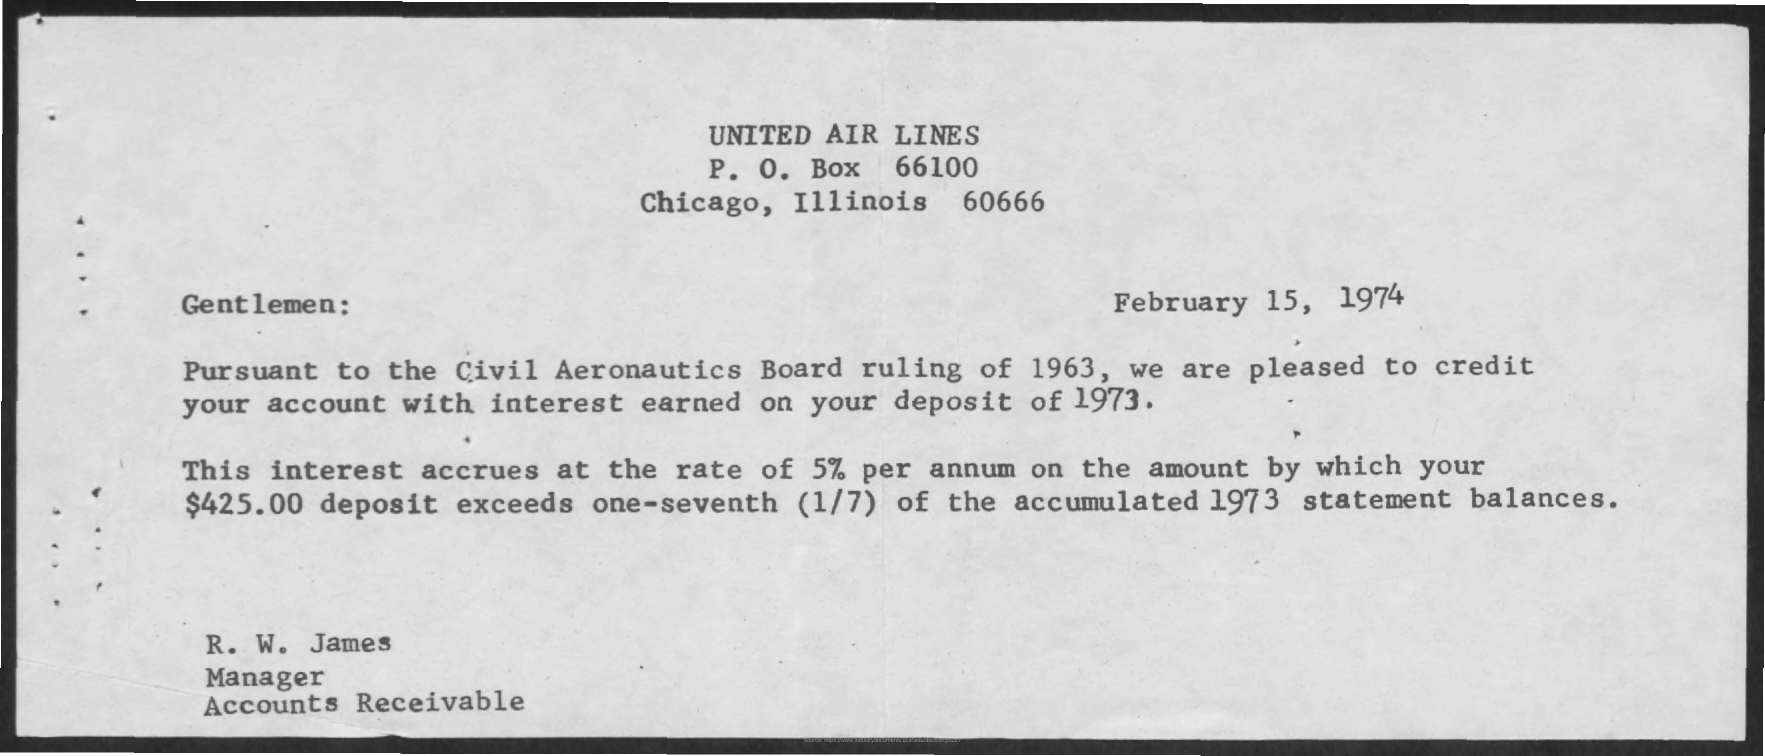What is the date mentioned in this document?
Your answer should be compact. February 15, 1974. What is the P.O.Box no given?
Keep it short and to the point. 66100. Who is the sender of this document?
Give a very brief answer. R. W. James. 